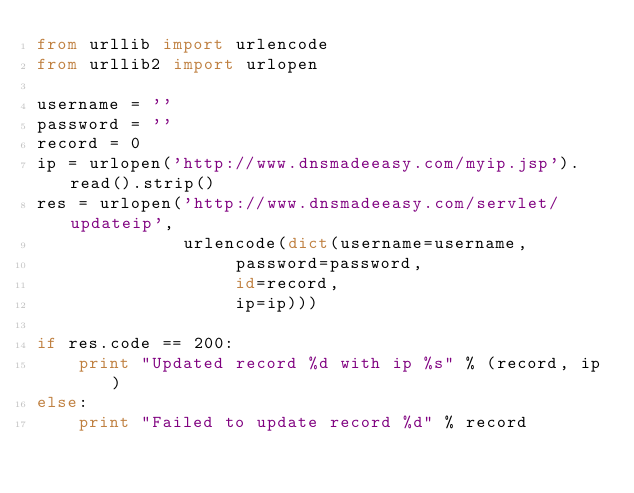Convert code to text. <code><loc_0><loc_0><loc_500><loc_500><_Python_>from urllib import urlencode
from urllib2 import urlopen

username = ''
password = ''
record = 0
ip = urlopen('http://www.dnsmadeeasy.com/myip.jsp').read().strip()
res = urlopen('http://www.dnsmadeeasy.com/servlet/updateip',
              urlencode(dict(username=username,
                   password=password,
                   id=record,
                   ip=ip)))

if res.code == 200:
    print "Updated record %d with ip %s" % (record, ip)
else:
    print "Failed to update record %d" % record
</code> 